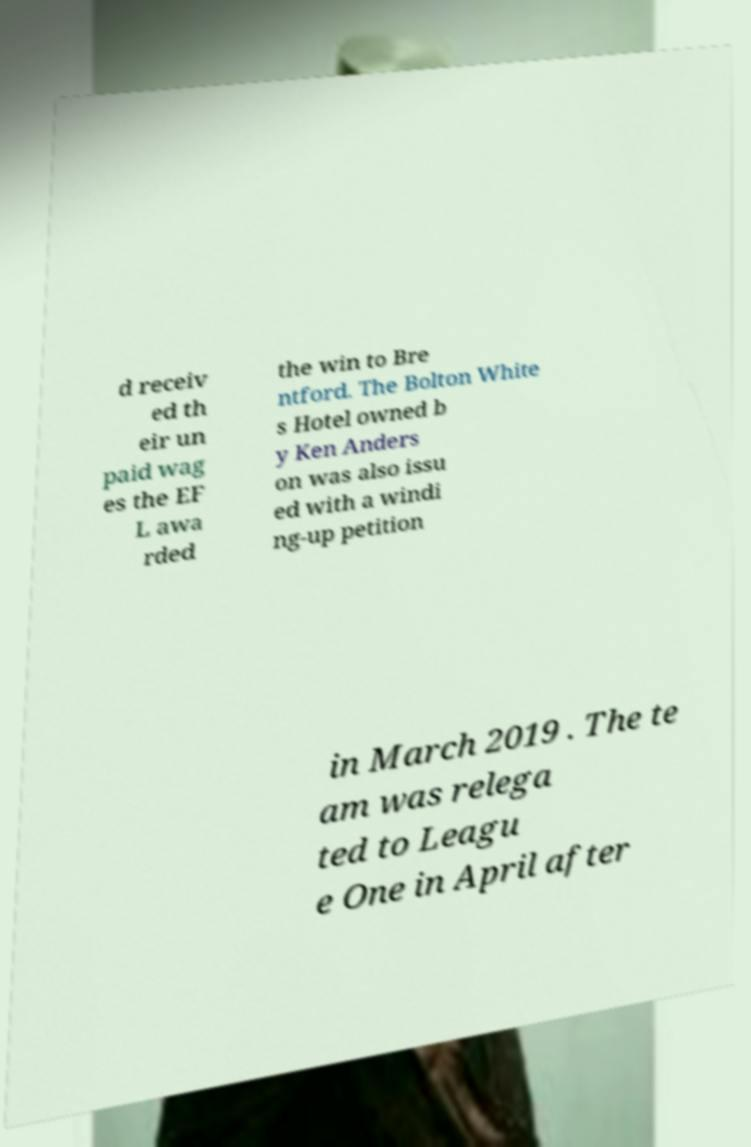Can you read and provide the text displayed in the image?This photo seems to have some interesting text. Can you extract and type it out for me? d receiv ed th eir un paid wag es the EF L awa rded the win to Bre ntford. The Bolton White s Hotel owned b y Ken Anders on was also issu ed with a windi ng-up petition in March 2019 . The te am was relega ted to Leagu e One in April after 